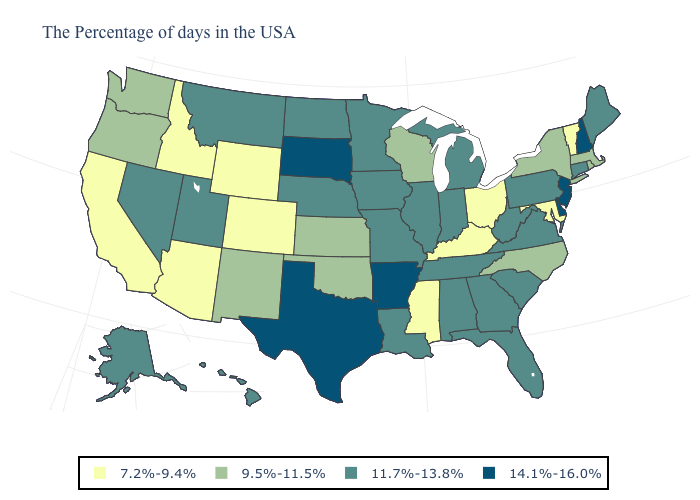How many symbols are there in the legend?
Be succinct. 4. What is the value of Idaho?
Keep it brief. 7.2%-9.4%. What is the value of Mississippi?
Keep it brief. 7.2%-9.4%. What is the lowest value in the USA?
Be succinct. 7.2%-9.4%. Name the states that have a value in the range 9.5%-11.5%?
Keep it brief. Massachusetts, Rhode Island, New York, North Carolina, Wisconsin, Kansas, Oklahoma, New Mexico, Washington, Oregon. Name the states that have a value in the range 9.5%-11.5%?
Be succinct. Massachusetts, Rhode Island, New York, North Carolina, Wisconsin, Kansas, Oklahoma, New Mexico, Washington, Oregon. What is the value of Massachusetts?
Be succinct. 9.5%-11.5%. Name the states that have a value in the range 14.1%-16.0%?
Keep it brief. New Hampshire, New Jersey, Delaware, Arkansas, Texas, South Dakota. Does Colorado have the lowest value in the USA?
Answer briefly. Yes. Does Colorado have the lowest value in the USA?
Quick response, please. Yes. Among the states that border Utah , does Nevada have the lowest value?
Concise answer only. No. What is the highest value in the Northeast ?
Answer briefly. 14.1%-16.0%. Does the first symbol in the legend represent the smallest category?
Short answer required. Yes. Among the states that border Arkansas , which have the highest value?
Answer briefly. Texas. Name the states that have a value in the range 11.7%-13.8%?
Keep it brief. Maine, Connecticut, Pennsylvania, Virginia, South Carolina, West Virginia, Florida, Georgia, Michigan, Indiana, Alabama, Tennessee, Illinois, Louisiana, Missouri, Minnesota, Iowa, Nebraska, North Dakota, Utah, Montana, Nevada, Alaska, Hawaii. 